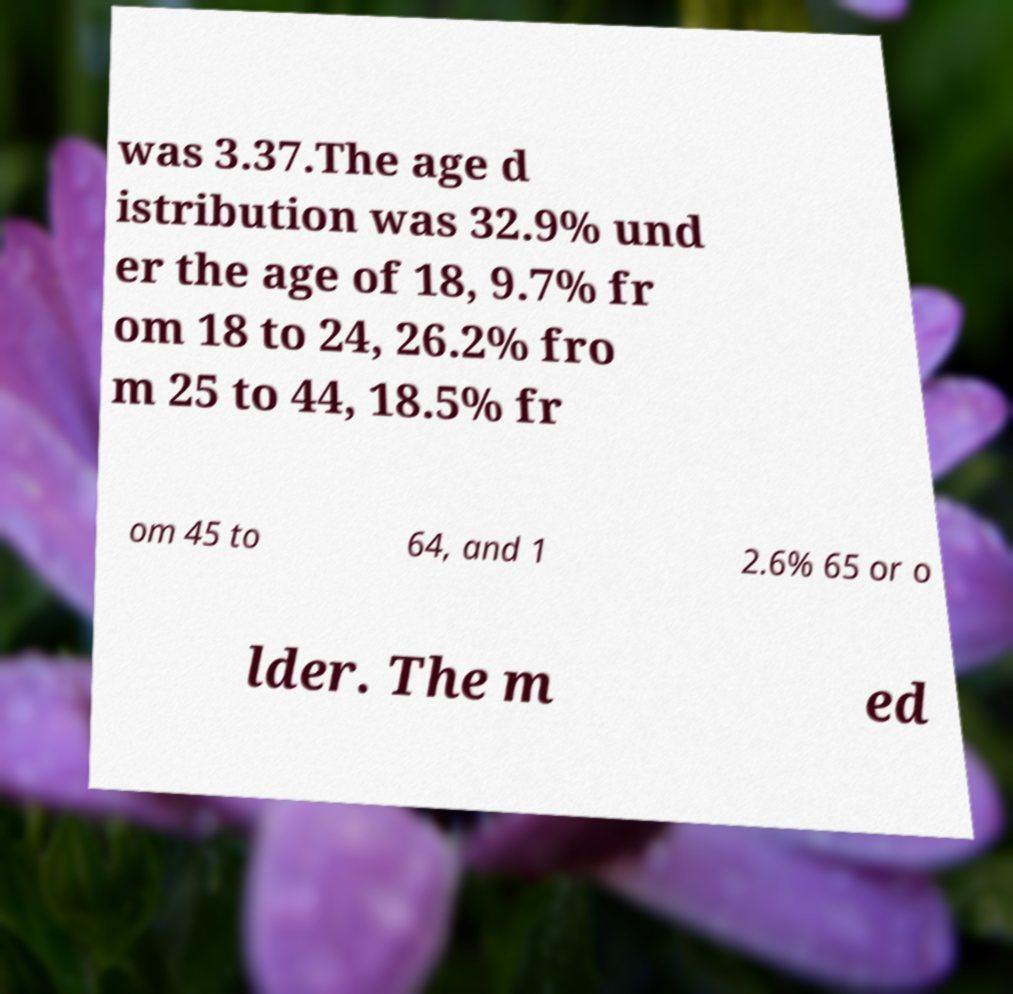Can you accurately transcribe the text from the provided image for me? was 3.37.The age d istribution was 32.9% und er the age of 18, 9.7% fr om 18 to 24, 26.2% fro m 25 to 44, 18.5% fr om 45 to 64, and 1 2.6% 65 or o lder. The m ed 